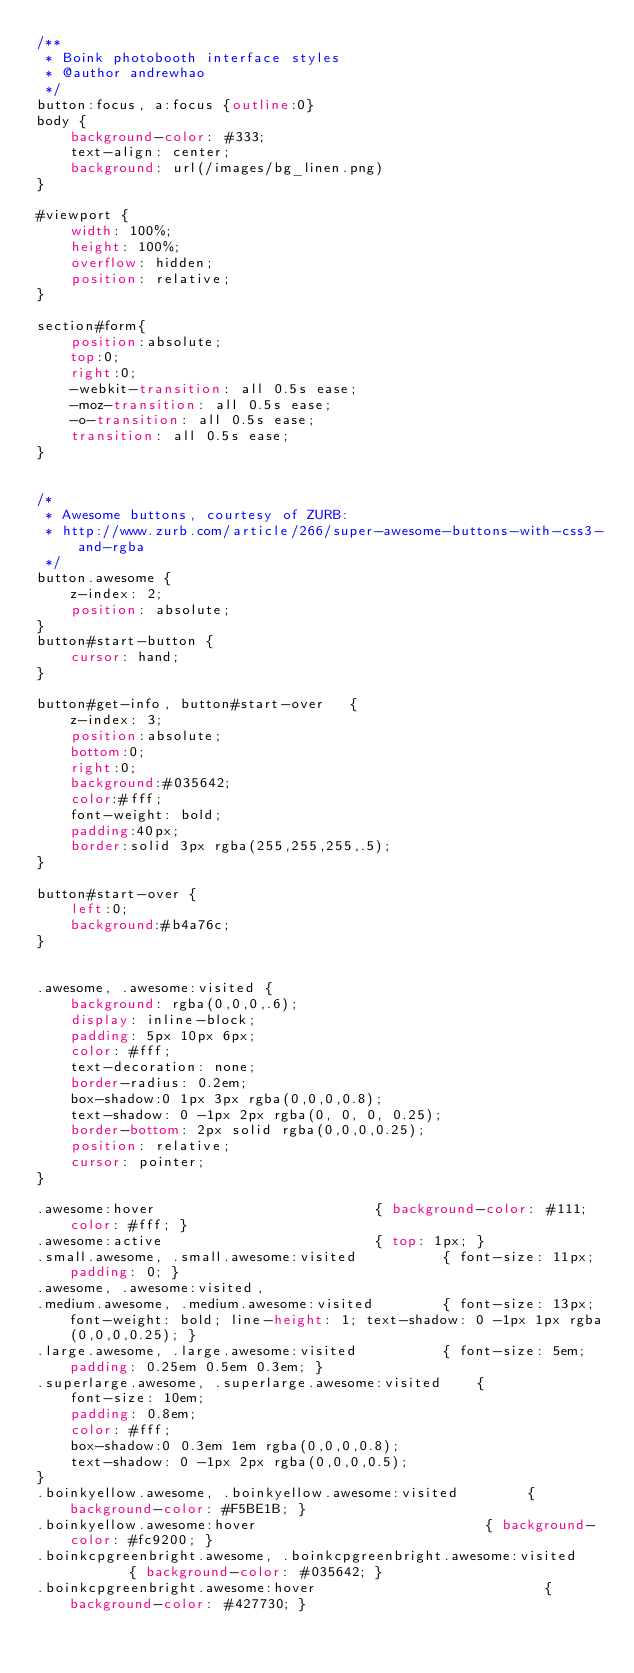Convert code to text. <code><loc_0><loc_0><loc_500><loc_500><_CSS_>/**
 * Boink photobooth interface styles
 * @author andrewhao
 */
button:focus, a:focus {outline:0}
body {
    background-color: #333;
    text-align: center;
    background: url(/images/bg_linen.png)
}

#viewport {
    width: 100%;
    height: 100%;
    overflow: hidden;
    position: relative;
}

section#form{
    position:absolute;
    top:0;
    right:0;
    -webkit-transition: all 0.5s ease;
    -moz-transition: all 0.5s ease;
    -o-transition: all 0.5s ease;
    transition: all 0.5s ease;
}


/*
 * Awesome buttons, courtesy of ZURB:
 * http://www.zurb.com/article/266/super-awesome-buttons-with-css3-and-rgba
 */
button.awesome {
    z-index: 2;
    position: absolute;
}
button#start-button {
    cursor: hand;
}

button#get-info, button#start-over   {
    z-index: 3;
    position:absolute;
    bottom:0;
    right:0;
    background:#035642;
    color:#fff;
    font-weight: bold;
    padding:40px;
    border:solid 3px rgba(255,255,255,.5);
}

button#start-over {
    left:0;
    background:#b4a76c;
}


.awesome, .awesome:visited {
    background: rgba(0,0,0,.6); 
    display: inline-block; 
    padding: 5px 10px 6px; 
    color: #fff; 
    text-decoration: none;
    border-radius: 0.2em;
    box-shadow:0 1px 3px rgba(0,0,0,0.8);
    text-shadow: 0 -1px 2px rgba(0, 0, 0, 0.25);
    border-bottom: 2px solid rgba(0,0,0,0.25);
    position: relative;
    cursor: pointer;
}

.awesome:hover                          { background-color: #111; color: #fff; }
.awesome:active                         { top: 1px; }
.small.awesome, .small.awesome:visited          { font-size: 11px; padding: 0; }
.awesome, .awesome:visited,
.medium.awesome, .medium.awesome:visited        { font-size: 13px; font-weight: bold; line-height: 1; text-shadow: 0 -1px 1px rgba(0,0,0,0.25); }
.large.awesome, .large.awesome:visited          { font-size: 5em; padding: 0.25em 0.5em 0.3em; }
.superlarge.awesome, .superlarge.awesome:visited    {
    font-size: 10em;
    padding: 0.8em;
    color: #fff;
    box-shadow:0 0.3em 1em rgba(0,0,0,0.8);
    text-shadow: 0 -1px 2px rgba(0,0,0,0.5);
}
.boinkyellow.awesome, .boinkyellow.awesome:visited        { background-color: #F5BE1B; }
.boinkyellow.awesome:hover                           { background-color: #fc9200; }
.boinkcpgreenbright.awesome, .boinkcpgreenbright.awesome:visited        { background-color: #035642; }
.boinkcpgreenbright.awesome:hover                           { background-color: #427730; }

</code> 